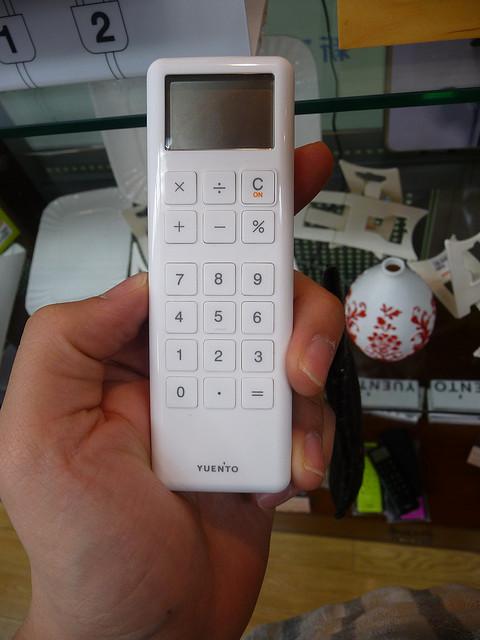Are the calculators turned on?
Concise answer only. No. What is in the man's hand?
Keep it brief. Calculator. Is this a smartphone?
Be succinct. No. What is the design on the vase?
Quick response, please. Flowers. What is the man holding?
Short answer required. Calculator. 